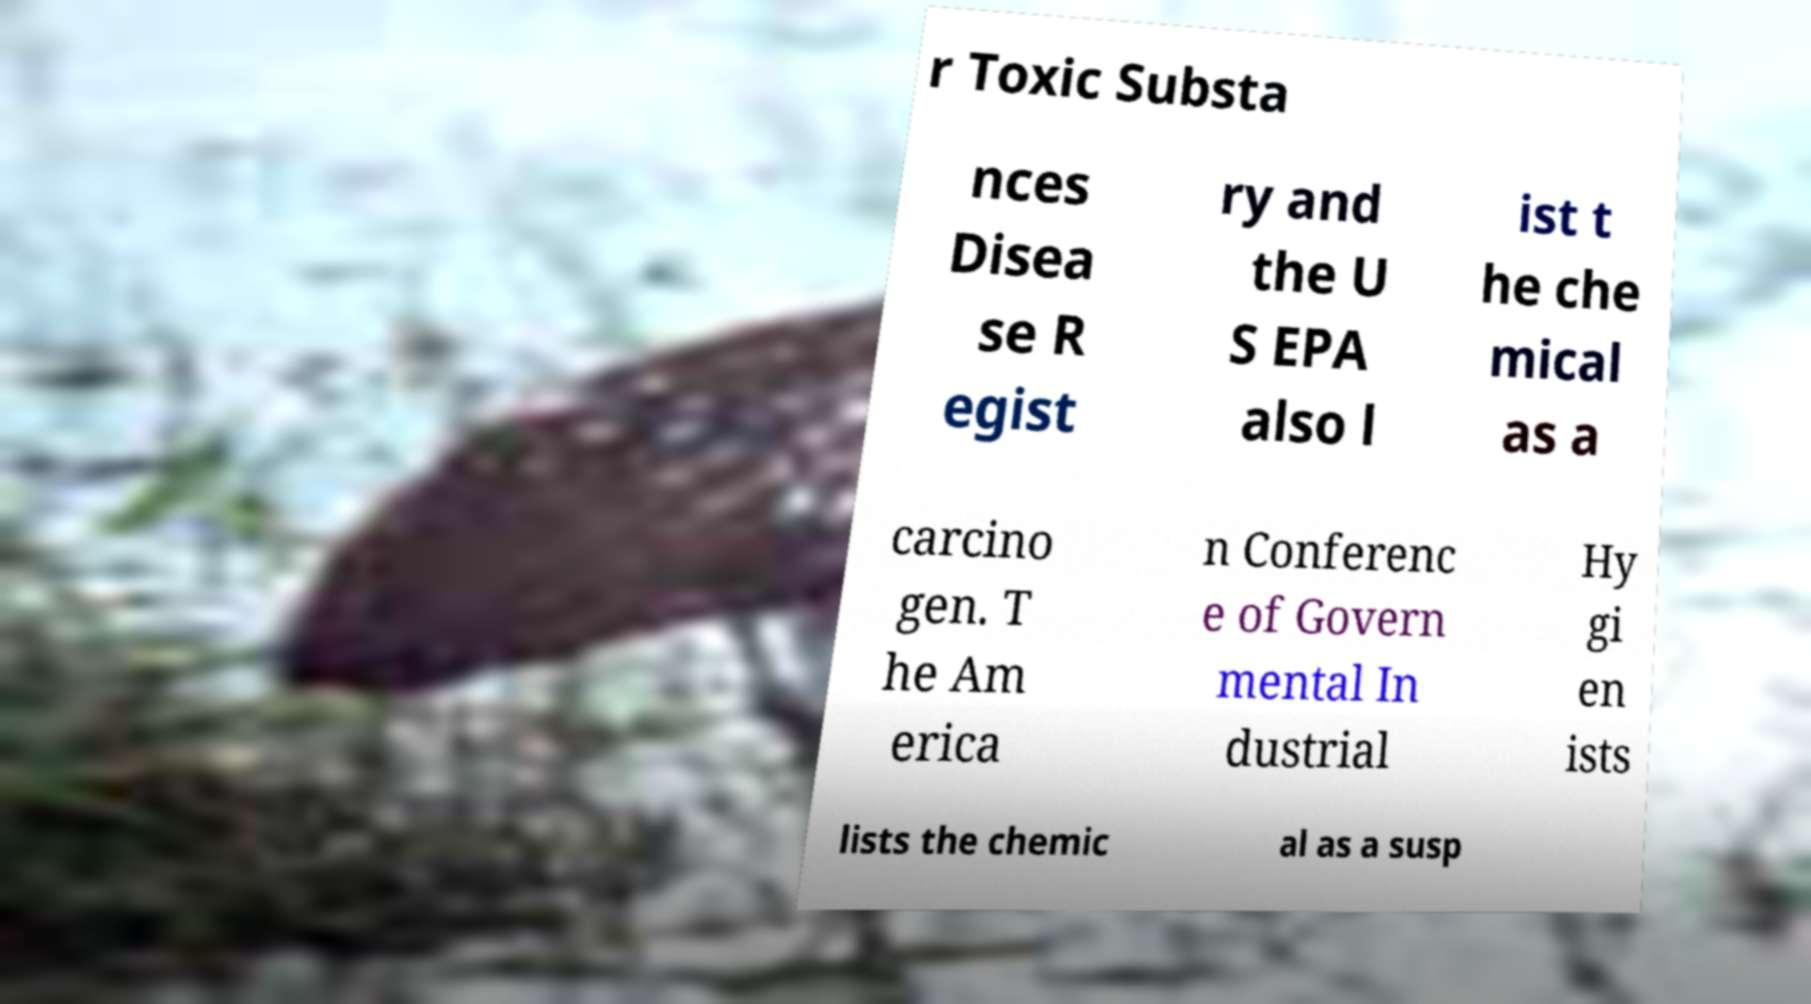Can you accurately transcribe the text from the provided image for me? r Toxic Substa nces Disea se R egist ry and the U S EPA also l ist t he che mical as a carcino gen. T he Am erica n Conferenc e of Govern mental In dustrial Hy gi en ists lists the chemic al as a susp 